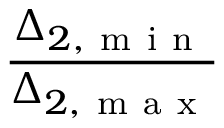<formula> <loc_0><loc_0><loc_500><loc_500>\frac { \Delta _ { 2 , m i n } } { \Delta _ { 2 , m a x } }</formula> 